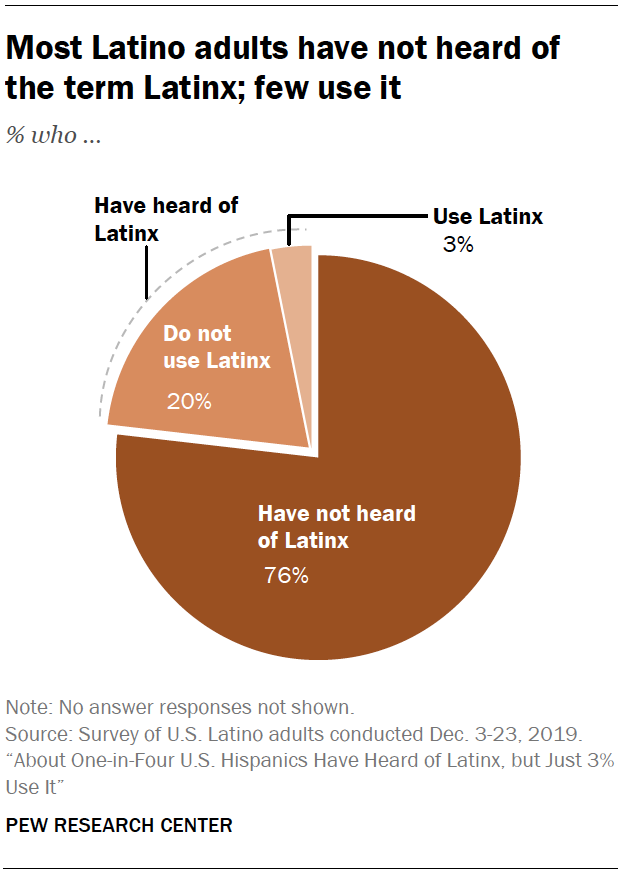Highlight a few significant elements in this photo. According to recent studies, only 0.138888889% of the population identifies as Latinx. Only 0.03% of the population identifies as Latinx. 